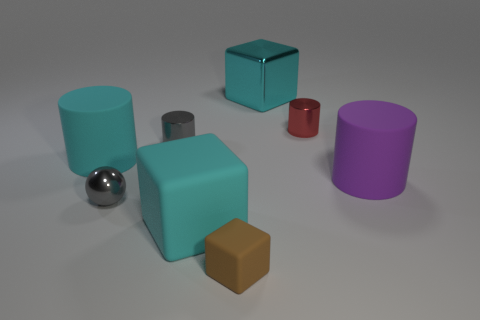What material is the brown block that is the same size as the red thing?
Provide a succinct answer. Rubber. What is the material of the big cyan cylinder left of the block that is behind the cyan rubber cube?
Provide a short and direct response. Rubber. Do the tiny object to the right of the small rubber thing and the small brown thing have the same shape?
Your answer should be very brief. No. What is the color of the small sphere that is the same material as the red cylinder?
Your answer should be very brief. Gray. There is a ball that is in front of the big metal block; what is its material?
Your response must be concise. Metal. There is a tiny red shiny object; is its shape the same as the big cyan rubber thing that is on the right side of the gray shiny sphere?
Make the answer very short. No. There is a cylinder that is both in front of the small gray cylinder and left of the big matte block; what material is it?
Provide a short and direct response. Rubber. What is the color of the shiny sphere that is the same size as the gray cylinder?
Your answer should be very brief. Gray. Do the small gray ball and the tiny cylinder to the left of the large cyan shiny block have the same material?
Offer a very short reply. Yes. What number of other things are there of the same size as the red object?
Provide a succinct answer. 3. 